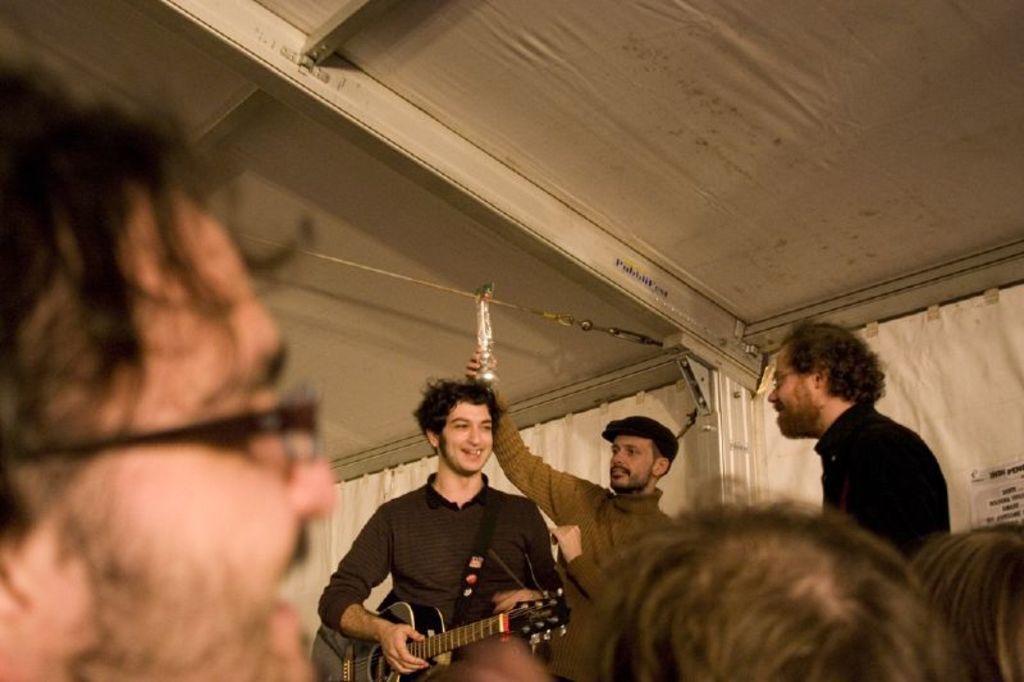In one or two sentences, can you explain what this image depicts? In this image, there are some persons standing and wearing colorful clothes. This person is wearing a guitar and smiling. This person is holding something with his hands. This person is wearing spectacles on his head. There is a wall behind this person. 